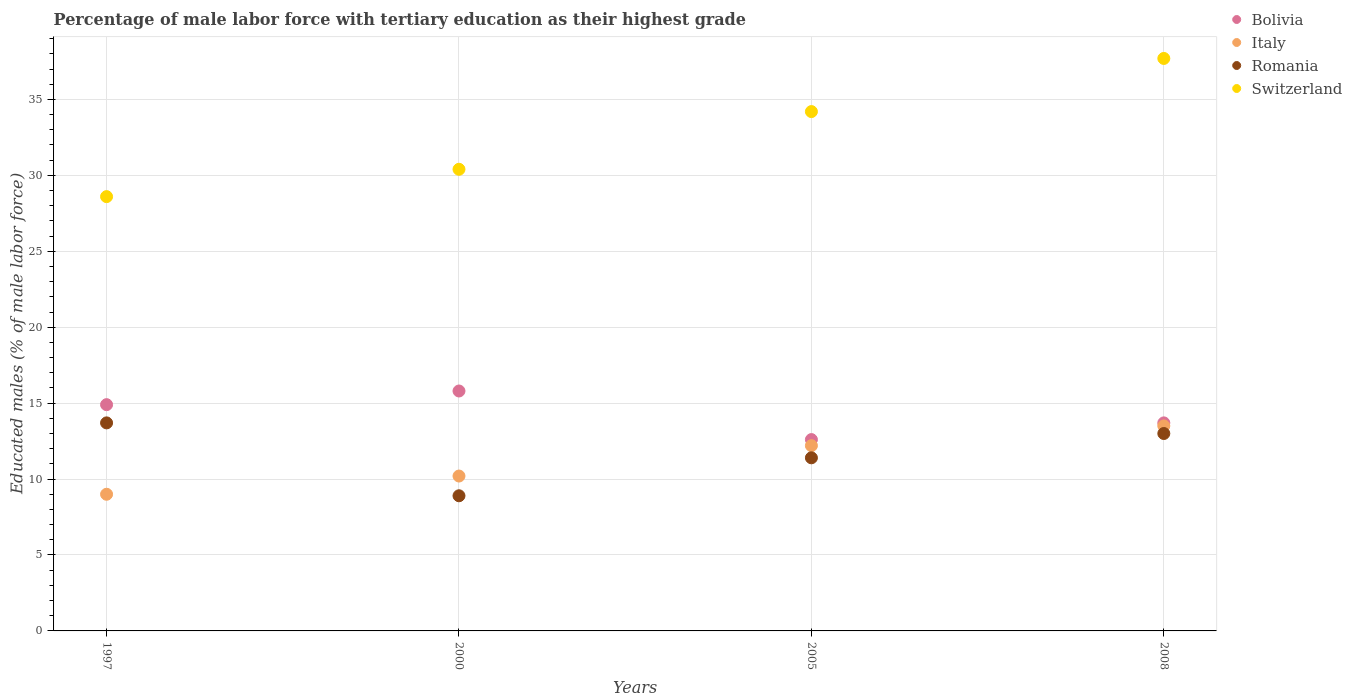How many different coloured dotlines are there?
Offer a very short reply. 4. Is the number of dotlines equal to the number of legend labels?
Offer a very short reply. Yes. What is the percentage of male labor force with tertiary education in Bolivia in 1997?
Your answer should be very brief. 14.9. Across all years, what is the maximum percentage of male labor force with tertiary education in Switzerland?
Ensure brevity in your answer.  37.7. Across all years, what is the minimum percentage of male labor force with tertiary education in Switzerland?
Make the answer very short. 28.6. In which year was the percentage of male labor force with tertiary education in Bolivia maximum?
Provide a short and direct response. 2000. In which year was the percentage of male labor force with tertiary education in Bolivia minimum?
Keep it short and to the point. 2005. What is the total percentage of male labor force with tertiary education in Romania in the graph?
Your answer should be very brief. 47. What is the difference between the percentage of male labor force with tertiary education in Italy in 1997 and that in 2005?
Give a very brief answer. -3.2. What is the difference between the percentage of male labor force with tertiary education in Bolivia in 2005 and the percentage of male labor force with tertiary education in Romania in 2008?
Offer a terse response. -0.4. What is the average percentage of male labor force with tertiary education in Bolivia per year?
Make the answer very short. 14.25. In the year 2005, what is the difference between the percentage of male labor force with tertiary education in Bolivia and percentage of male labor force with tertiary education in Italy?
Provide a short and direct response. 0.4. In how many years, is the percentage of male labor force with tertiary education in Bolivia greater than 27 %?
Your answer should be very brief. 0. What is the ratio of the percentage of male labor force with tertiary education in Bolivia in 2000 to that in 2005?
Provide a short and direct response. 1.25. What is the difference between the highest and the second highest percentage of male labor force with tertiary education in Bolivia?
Ensure brevity in your answer.  0.9. What is the difference between the highest and the lowest percentage of male labor force with tertiary education in Switzerland?
Offer a terse response. 9.1. Is the percentage of male labor force with tertiary education in Italy strictly less than the percentage of male labor force with tertiary education in Romania over the years?
Make the answer very short. No. How many dotlines are there?
Keep it short and to the point. 4. How many years are there in the graph?
Your answer should be very brief. 4. Does the graph contain any zero values?
Your answer should be very brief. No. How are the legend labels stacked?
Your response must be concise. Vertical. What is the title of the graph?
Offer a very short reply. Percentage of male labor force with tertiary education as their highest grade. What is the label or title of the X-axis?
Keep it short and to the point. Years. What is the label or title of the Y-axis?
Your response must be concise. Educated males (% of male labor force). What is the Educated males (% of male labor force) in Bolivia in 1997?
Give a very brief answer. 14.9. What is the Educated males (% of male labor force) of Romania in 1997?
Your response must be concise. 13.7. What is the Educated males (% of male labor force) of Switzerland in 1997?
Ensure brevity in your answer.  28.6. What is the Educated males (% of male labor force) in Bolivia in 2000?
Make the answer very short. 15.8. What is the Educated males (% of male labor force) in Italy in 2000?
Provide a short and direct response. 10.2. What is the Educated males (% of male labor force) of Romania in 2000?
Your answer should be compact. 8.9. What is the Educated males (% of male labor force) of Switzerland in 2000?
Ensure brevity in your answer.  30.4. What is the Educated males (% of male labor force) of Bolivia in 2005?
Ensure brevity in your answer.  12.6. What is the Educated males (% of male labor force) in Italy in 2005?
Ensure brevity in your answer.  12.2. What is the Educated males (% of male labor force) in Romania in 2005?
Keep it short and to the point. 11.4. What is the Educated males (% of male labor force) of Switzerland in 2005?
Your response must be concise. 34.2. What is the Educated males (% of male labor force) of Bolivia in 2008?
Make the answer very short. 13.7. What is the Educated males (% of male labor force) of Romania in 2008?
Offer a very short reply. 13. What is the Educated males (% of male labor force) in Switzerland in 2008?
Your answer should be very brief. 37.7. Across all years, what is the maximum Educated males (% of male labor force) in Bolivia?
Offer a terse response. 15.8. Across all years, what is the maximum Educated males (% of male labor force) in Italy?
Keep it short and to the point. 13.5. Across all years, what is the maximum Educated males (% of male labor force) of Romania?
Offer a terse response. 13.7. Across all years, what is the maximum Educated males (% of male labor force) in Switzerland?
Your answer should be compact. 37.7. Across all years, what is the minimum Educated males (% of male labor force) of Bolivia?
Offer a very short reply. 12.6. Across all years, what is the minimum Educated males (% of male labor force) in Romania?
Your answer should be very brief. 8.9. Across all years, what is the minimum Educated males (% of male labor force) of Switzerland?
Your answer should be very brief. 28.6. What is the total Educated males (% of male labor force) of Italy in the graph?
Make the answer very short. 44.9. What is the total Educated males (% of male labor force) in Romania in the graph?
Offer a very short reply. 47. What is the total Educated males (% of male labor force) of Switzerland in the graph?
Offer a terse response. 130.9. What is the difference between the Educated males (% of male labor force) in Romania in 1997 and that in 2000?
Ensure brevity in your answer.  4.8. What is the difference between the Educated males (% of male labor force) in Bolivia in 1997 and that in 2005?
Your answer should be compact. 2.3. What is the difference between the Educated males (% of male labor force) in Italy in 2000 and that in 2005?
Your answer should be very brief. -2. What is the difference between the Educated males (% of male labor force) in Romania in 2000 and that in 2005?
Offer a terse response. -2.5. What is the difference between the Educated males (% of male labor force) in Switzerland in 2000 and that in 2005?
Provide a short and direct response. -3.8. What is the difference between the Educated males (% of male labor force) in Bolivia in 2005 and that in 2008?
Provide a short and direct response. -1.1. What is the difference between the Educated males (% of male labor force) in Romania in 2005 and that in 2008?
Your answer should be compact. -1.6. What is the difference between the Educated males (% of male labor force) in Switzerland in 2005 and that in 2008?
Keep it short and to the point. -3.5. What is the difference between the Educated males (% of male labor force) of Bolivia in 1997 and the Educated males (% of male labor force) of Romania in 2000?
Offer a very short reply. 6. What is the difference between the Educated males (% of male labor force) in Bolivia in 1997 and the Educated males (% of male labor force) in Switzerland in 2000?
Provide a short and direct response. -15.5. What is the difference between the Educated males (% of male labor force) in Italy in 1997 and the Educated males (% of male labor force) in Romania in 2000?
Give a very brief answer. 0.1. What is the difference between the Educated males (% of male labor force) in Italy in 1997 and the Educated males (% of male labor force) in Switzerland in 2000?
Your answer should be very brief. -21.4. What is the difference between the Educated males (% of male labor force) in Romania in 1997 and the Educated males (% of male labor force) in Switzerland in 2000?
Keep it short and to the point. -16.7. What is the difference between the Educated males (% of male labor force) of Bolivia in 1997 and the Educated males (% of male labor force) of Italy in 2005?
Offer a terse response. 2.7. What is the difference between the Educated males (% of male labor force) in Bolivia in 1997 and the Educated males (% of male labor force) in Switzerland in 2005?
Your response must be concise. -19.3. What is the difference between the Educated males (% of male labor force) of Italy in 1997 and the Educated males (% of male labor force) of Romania in 2005?
Ensure brevity in your answer.  -2.4. What is the difference between the Educated males (% of male labor force) in Italy in 1997 and the Educated males (% of male labor force) in Switzerland in 2005?
Make the answer very short. -25.2. What is the difference between the Educated males (% of male labor force) in Romania in 1997 and the Educated males (% of male labor force) in Switzerland in 2005?
Your answer should be very brief. -20.5. What is the difference between the Educated males (% of male labor force) of Bolivia in 1997 and the Educated males (% of male labor force) of Switzerland in 2008?
Offer a very short reply. -22.8. What is the difference between the Educated males (% of male labor force) in Italy in 1997 and the Educated males (% of male labor force) in Romania in 2008?
Your response must be concise. -4. What is the difference between the Educated males (% of male labor force) in Italy in 1997 and the Educated males (% of male labor force) in Switzerland in 2008?
Keep it short and to the point. -28.7. What is the difference between the Educated males (% of male labor force) of Bolivia in 2000 and the Educated males (% of male labor force) of Italy in 2005?
Offer a very short reply. 3.6. What is the difference between the Educated males (% of male labor force) in Bolivia in 2000 and the Educated males (% of male labor force) in Romania in 2005?
Your answer should be very brief. 4.4. What is the difference between the Educated males (% of male labor force) of Bolivia in 2000 and the Educated males (% of male labor force) of Switzerland in 2005?
Offer a terse response. -18.4. What is the difference between the Educated males (% of male labor force) in Italy in 2000 and the Educated males (% of male labor force) in Romania in 2005?
Keep it short and to the point. -1.2. What is the difference between the Educated males (% of male labor force) in Romania in 2000 and the Educated males (% of male labor force) in Switzerland in 2005?
Your response must be concise. -25.3. What is the difference between the Educated males (% of male labor force) in Bolivia in 2000 and the Educated males (% of male labor force) in Italy in 2008?
Ensure brevity in your answer.  2.3. What is the difference between the Educated males (% of male labor force) of Bolivia in 2000 and the Educated males (% of male labor force) of Romania in 2008?
Make the answer very short. 2.8. What is the difference between the Educated males (% of male labor force) in Bolivia in 2000 and the Educated males (% of male labor force) in Switzerland in 2008?
Make the answer very short. -21.9. What is the difference between the Educated males (% of male labor force) in Italy in 2000 and the Educated males (% of male labor force) in Romania in 2008?
Your answer should be compact. -2.8. What is the difference between the Educated males (% of male labor force) in Italy in 2000 and the Educated males (% of male labor force) in Switzerland in 2008?
Offer a terse response. -27.5. What is the difference between the Educated males (% of male labor force) in Romania in 2000 and the Educated males (% of male labor force) in Switzerland in 2008?
Provide a succinct answer. -28.8. What is the difference between the Educated males (% of male labor force) in Bolivia in 2005 and the Educated males (% of male labor force) in Italy in 2008?
Your response must be concise. -0.9. What is the difference between the Educated males (% of male labor force) in Bolivia in 2005 and the Educated males (% of male labor force) in Switzerland in 2008?
Ensure brevity in your answer.  -25.1. What is the difference between the Educated males (% of male labor force) of Italy in 2005 and the Educated males (% of male labor force) of Romania in 2008?
Give a very brief answer. -0.8. What is the difference between the Educated males (% of male labor force) of Italy in 2005 and the Educated males (% of male labor force) of Switzerland in 2008?
Keep it short and to the point. -25.5. What is the difference between the Educated males (% of male labor force) of Romania in 2005 and the Educated males (% of male labor force) of Switzerland in 2008?
Provide a short and direct response. -26.3. What is the average Educated males (% of male labor force) in Bolivia per year?
Offer a terse response. 14.25. What is the average Educated males (% of male labor force) in Italy per year?
Give a very brief answer. 11.22. What is the average Educated males (% of male labor force) in Romania per year?
Provide a succinct answer. 11.75. What is the average Educated males (% of male labor force) of Switzerland per year?
Make the answer very short. 32.73. In the year 1997, what is the difference between the Educated males (% of male labor force) in Bolivia and Educated males (% of male labor force) in Italy?
Your response must be concise. 5.9. In the year 1997, what is the difference between the Educated males (% of male labor force) of Bolivia and Educated males (% of male labor force) of Switzerland?
Offer a terse response. -13.7. In the year 1997, what is the difference between the Educated males (% of male labor force) of Italy and Educated males (% of male labor force) of Romania?
Your answer should be compact. -4.7. In the year 1997, what is the difference between the Educated males (% of male labor force) of Italy and Educated males (% of male labor force) of Switzerland?
Your answer should be very brief. -19.6. In the year 1997, what is the difference between the Educated males (% of male labor force) in Romania and Educated males (% of male labor force) in Switzerland?
Ensure brevity in your answer.  -14.9. In the year 2000, what is the difference between the Educated males (% of male labor force) of Bolivia and Educated males (% of male labor force) of Romania?
Make the answer very short. 6.9. In the year 2000, what is the difference between the Educated males (% of male labor force) of Bolivia and Educated males (% of male labor force) of Switzerland?
Your answer should be very brief. -14.6. In the year 2000, what is the difference between the Educated males (% of male labor force) in Italy and Educated males (% of male labor force) in Romania?
Provide a succinct answer. 1.3. In the year 2000, what is the difference between the Educated males (% of male labor force) of Italy and Educated males (% of male labor force) of Switzerland?
Provide a succinct answer. -20.2. In the year 2000, what is the difference between the Educated males (% of male labor force) of Romania and Educated males (% of male labor force) of Switzerland?
Provide a succinct answer. -21.5. In the year 2005, what is the difference between the Educated males (% of male labor force) in Bolivia and Educated males (% of male labor force) in Romania?
Provide a short and direct response. 1.2. In the year 2005, what is the difference between the Educated males (% of male labor force) of Bolivia and Educated males (% of male labor force) of Switzerland?
Your response must be concise. -21.6. In the year 2005, what is the difference between the Educated males (% of male labor force) in Italy and Educated males (% of male labor force) in Switzerland?
Your answer should be compact. -22. In the year 2005, what is the difference between the Educated males (% of male labor force) of Romania and Educated males (% of male labor force) of Switzerland?
Keep it short and to the point. -22.8. In the year 2008, what is the difference between the Educated males (% of male labor force) in Bolivia and Educated males (% of male labor force) in Romania?
Your response must be concise. 0.7. In the year 2008, what is the difference between the Educated males (% of male labor force) of Italy and Educated males (% of male labor force) of Romania?
Your response must be concise. 0.5. In the year 2008, what is the difference between the Educated males (% of male labor force) of Italy and Educated males (% of male labor force) of Switzerland?
Make the answer very short. -24.2. In the year 2008, what is the difference between the Educated males (% of male labor force) of Romania and Educated males (% of male labor force) of Switzerland?
Give a very brief answer. -24.7. What is the ratio of the Educated males (% of male labor force) in Bolivia in 1997 to that in 2000?
Provide a short and direct response. 0.94. What is the ratio of the Educated males (% of male labor force) in Italy in 1997 to that in 2000?
Your answer should be very brief. 0.88. What is the ratio of the Educated males (% of male labor force) of Romania in 1997 to that in 2000?
Give a very brief answer. 1.54. What is the ratio of the Educated males (% of male labor force) of Switzerland in 1997 to that in 2000?
Your answer should be very brief. 0.94. What is the ratio of the Educated males (% of male labor force) of Bolivia in 1997 to that in 2005?
Give a very brief answer. 1.18. What is the ratio of the Educated males (% of male labor force) of Italy in 1997 to that in 2005?
Your response must be concise. 0.74. What is the ratio of the Educated males (% of male labor force) in Romania in 1997 to that in 2005?
Your response must be concise. 1.2. What is the ratio of the Educated males (% of male labor force) in Switzerland in 1997 to that in 2005?
Offer a very short reply. 0.84. What is the ratio of the Educated males (% of male labor force) in Bolivia in 1997 to that in 2008?
Offer a terse response. 1.09. What is the ratio of the Educated males (% of male labor force) of Romania in 1997 to that in 2008?
Offer a terse response. 1.05. What is the ratio of the Educated males (% of male labor force) in Switzerland in 1997 to that in 2008?
Your answer should be very brief. 0.76. What is the ratio of the Educated males (% of male labor force) of Bolivia in 2000 to that in 2005?
Your answer should be very brief. 1.25. What is the ratio of the Educated males (% of male labor force) in Italy in 2000 to that in 2005?
Give a very brief answer. 0.84. What is the ratio of the Educated males (% of male labor force) of Romania in 2000 to that in 2005?
Ensure brevity in your answer.  0.78. What is the ratio of the Educated males (% of male labor force) in Bolivia in 2000 to that in 2008?
Give a very brief answer. 1.15. What is the ratio of the Educated males (% of male labor force) in Italy in 2000 to that in 2008?
Provide a succinct answer. 0.76. What is the ratio of the Educated males (% of male labor force) in Romania in 2000 to that in 2008?
Give a very brief answer. 0.68. What is the ratio of the Educated males (% of male labor force) of Switzerland in 2000 to that in 2008?
Provide a succinct answer. 0.81. What is the ratio of the Educated males (% of male labor force) in Bolivia in 2005 to that in 2008?
Offer a very short reply. 0.92. What is the ratio of the Educated males (% of male labor force) of Italy in 2005 to that in 2008?
Give a very brief answer. 0.9. What is the ratio of the Educated males (% of male labor force) in Romania in 2005 to that in 2008?
Provide a succinct answer. 0.88. What is the ratio of the Educated males (% of male labor force) in Switzerland in 2005 to that in 2008?
Your answer should be very brief. 0.91. What is the difference between the highest and the second highest Educated males (% of male labor force) in Bolivia?
Your answer should be compact. 0.9. What is the difference between the highest and the second highest Educated males (% of male labor force) in Italy?
Provide a succinct answer. 1.3. What is the difference between the highest and the second highest Educated males (% of male labor force) in Romania?
Provide a short and direct response. 0.7. What is the difference between the highest and the second highest Educated males (% of male labor force) in Switzerland?
Provide a short and direct response. 3.5. What is the difference between the highest and the lowest Educated males (% of male labor force) in Romania?
Offer a terse response. 4.8. 